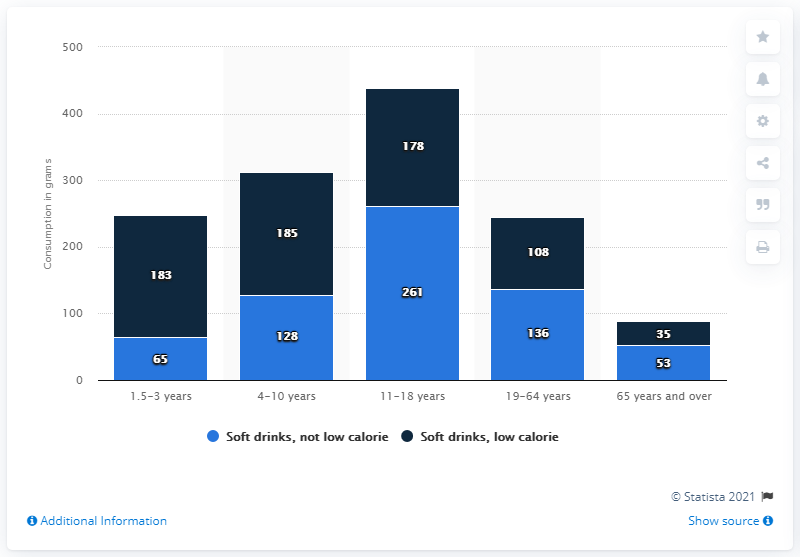Point out several critical features in this image. According to the given information, the age group with the smallest difference between non-low calorie soft drinks and low calorie soft drinks is 65 years and older. The consumption of non-low calorie soft drinks by individuals within the age group of 11-18 is 261. 